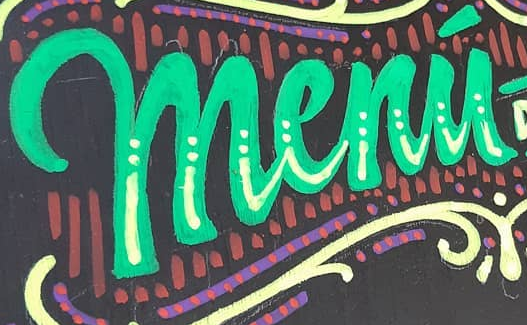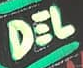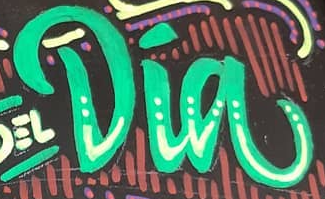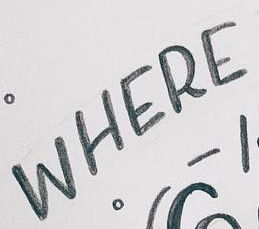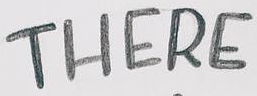What text is displayed in these images sequentially, separated by a semicolon? menú; DEL; Dia; WHERE; THERE 